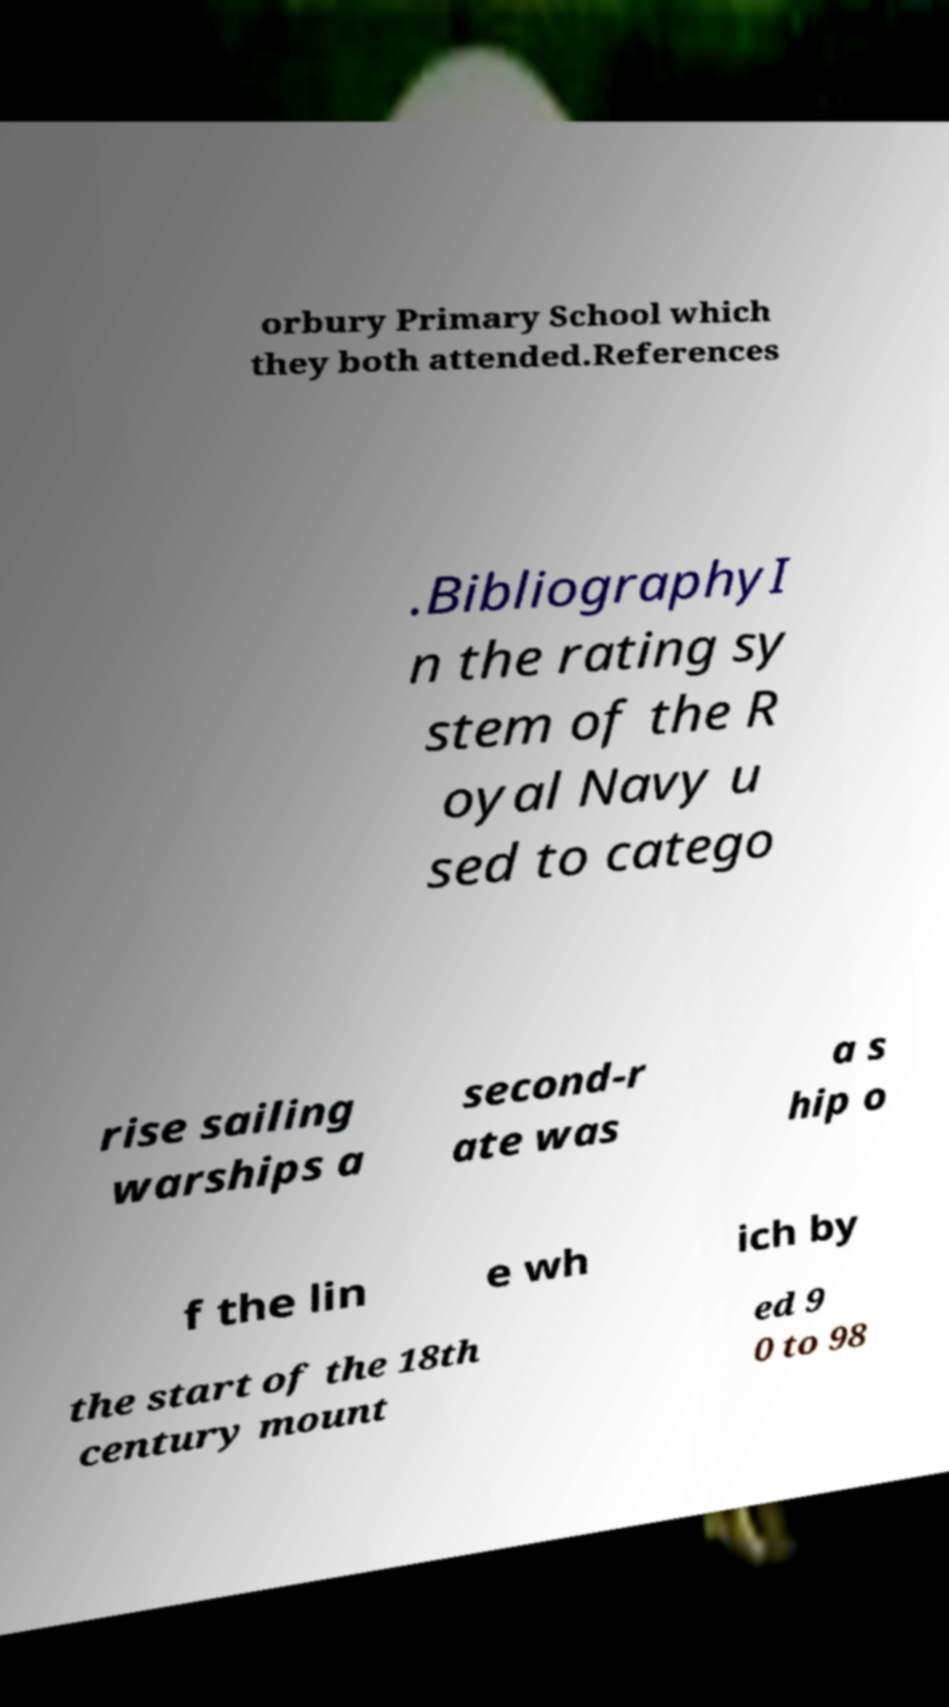I need the written content from this picture converted into text. Can you do that? orbury Primary School which they both attended.References .BibliographyI n the rating sy stem of the R oyal Navy u sed to catego rise sailing warships a second-r ate was a s hip o f the lin e wh ich by the start of the 18th century mount ed 9 0 to 98 